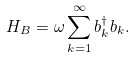<formula> <loc_0><loc_0><loc_500><loc_500>H _ { B } = \omega \sum _ { k = 1 } ^ { \infty } b _ { k } ^ { \dag } b _ { k } .</formula> 